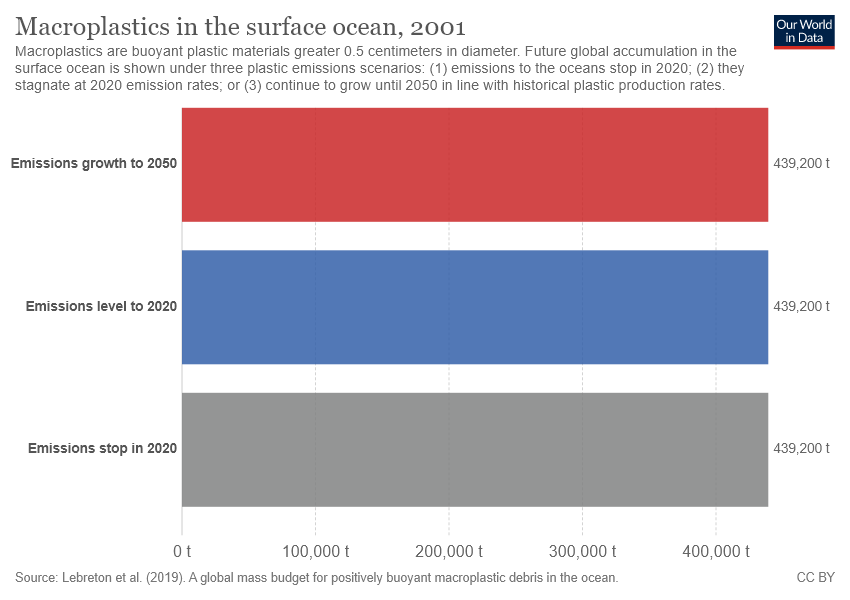Outline some significant characteristics in this image. The average of 439200 and... is 439200. Yes, all values are the same. 